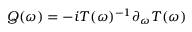<formula> <loc_0><loc_0><loc_500><loc_500>Q ( \omega ) = - i T ( \omega ) ^ { - 1 } \partial _ { \omega } T ( \omega )</formula> 